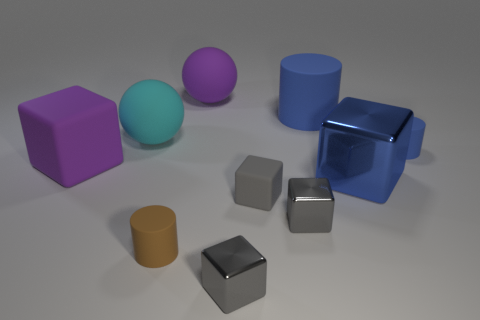Subtract all gray cubes. How many were subtracted if there are1gray cubes left? 2 Subtract all big rubber cubes. How many cubes are left? 4 Subtract 4 cubes. How many cubes are left? 1 Subtract all blue blocks. How many blocks are left? 4 Subtract all spheres. How many objects are left? 8 Subtract 0 red balls. How many objects are left? 10 Subtract all blue spheres. Subtract all yellow cubes. How many spheres are left? 2 Subtract all cyan cylinders. How many gray blocks are left? 3 Subtract all big red cubes. Subtract all matte cylinders. How many objects are left? 7 Add 7 small gray rubber blocks. How many small gray rubber blocks are left? 8 